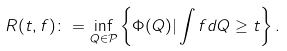Convert formula to latex. <formula><loc_0><loc_0><loc_500><loc_500>R ( t , f ) \colon = \inf _ { Q \in \mathcal { P } } \left \{ \Phi ( Q ) | \int f d Q \geq t \right \} .</formula> 